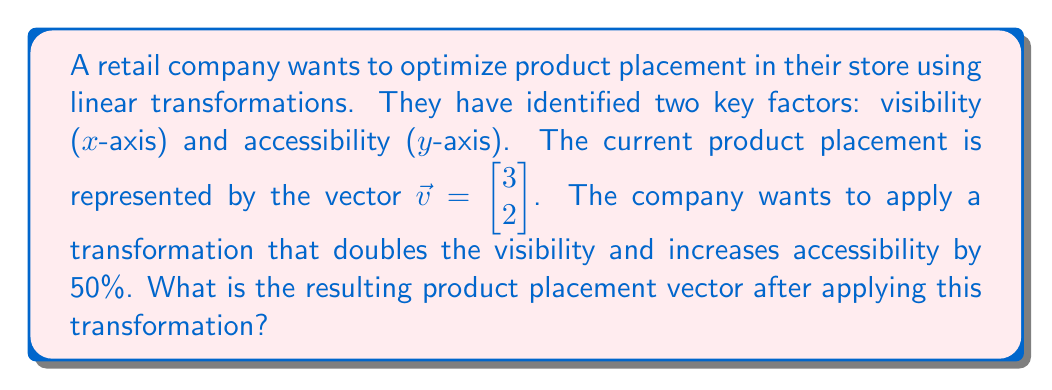Teach me how to tackle this problem. To solve this problem, we need to follow these steps:

1. Identify the transformation matrix:
   The transformation doubles the x-coordinate (visibility) and increases the y-coordinate (accessibility) by 50%.
   This can be represented by the matrix:
   $$A = \begin{bmatrix} 2 & 0 \\ 0 & 1.5 \end{bmatrix}$$

2. Apply the transformation to the initial vector:
   We need to multiply the transformation matrix by the initial vector.
   $$\vec{v}_{new} = A\vec{v}$$

3. Perform the matrix multiplication:
   $$\begin{bmatrix} 2 & 0 \\ 0 & 1.5 \end{bmatrix} \begin{bmatrix} 3 \\ 2 \end{bmatrix} = \begin{bmatrix} 2(3) \\ 1.5(2) \end{bmatrix} = \begin{bmatrix} 6 \\ 3 \end{bmatrix}$$

Therefore, the new product placement vector after applying the transformation is $\begin{bmatrix} 6 \\ 3 \end{bmatrix}$.
Answer: $\begin{bmatrix} 6 \\ 3 \end{bmatrix}$ 